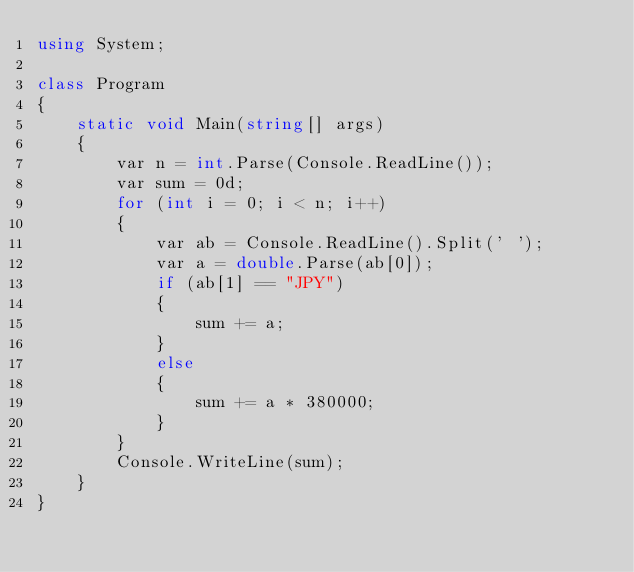Convert code to text. <code><loc_0><loc_0><loc_500><loc_500><_C#_>using System;

class Program
{
    static void Main(string[] args)
    {
        var n = int.Parse(Console.ReadLine());
        var sum = 0d;
        for (int i = 0; i < n; i++)
        {
            var ab = Console.ReadLine().Split(' ');
            var a = double.Parse(ab[0]);
            if (ab[1] == "JPY")
            {
                sum += a;
            }
            else
            {
                sum += a * 380000;
            }
        }
        Console.WriteLine(sum);
    }
}
</code> 